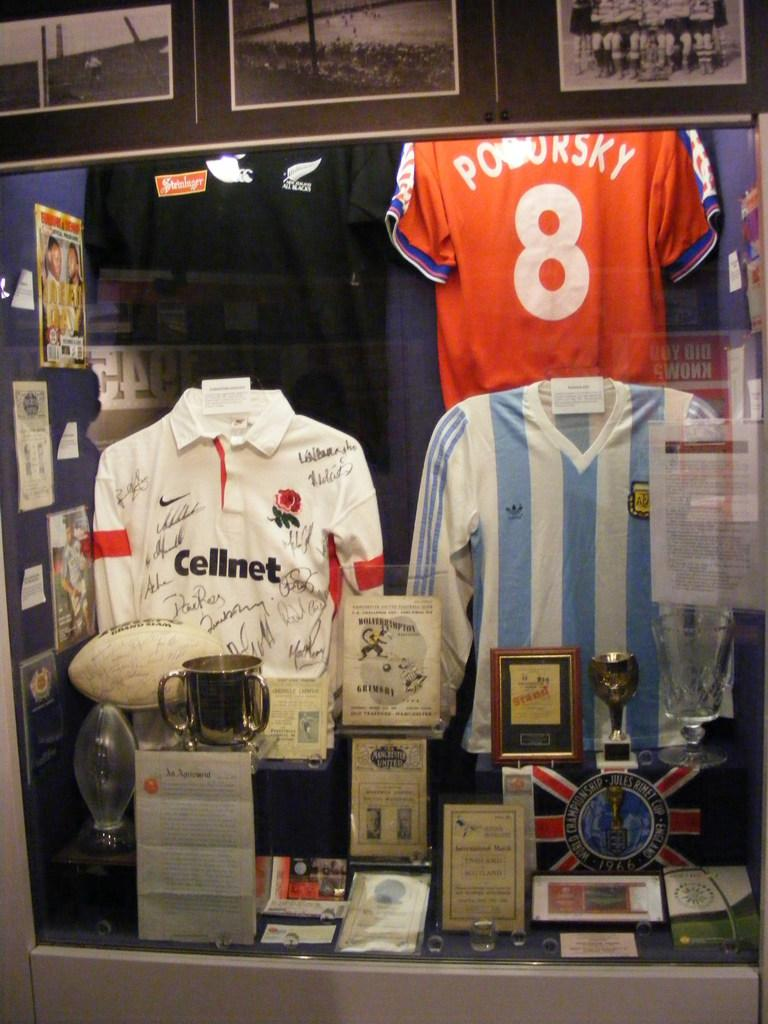<image>
Share a concise interpretation of the image provided. Three soccer's jerseys and the orange one have the number 8 on the back. 